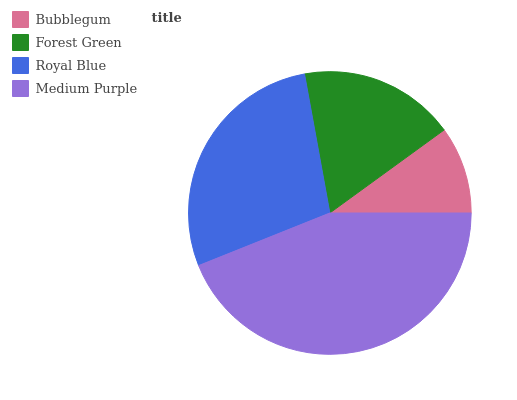Is Bubblegum the minimum?
Answer yes or no. Yes. Is Medium Purple the maximum?
Answer yes or no. Yes. Is Forest Green the minimum?
Answer yes or no. No. Is Forest Green the maximum?
Answer yes or no. No. Is Forest Green greater than Bubblegum?
Answer yes or no. Yes. Is Bubblegum less than Forest Green?
Answer yes or no. Yes. Is Bubblegum greater than Forest Green?
Answer yes or no. No. Is Forest Green less than Bubblegum?
Answer yes or no. No. Is Royal Blue the high median?
Answer yes or no. Yes. Is Forest Green the low median?
Answer yes or no. Yes. Is Forest Green the high median?
Answer yes or no. No. Is Medium Purple the low median?
Answer yes or no. No. 